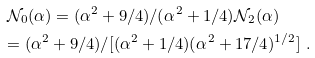<formula> <loc_0><loc_0><loc_500><loc_500>\mathcal { N } _ { 0 } ( \alpha ) = ( \alpha ^ { 2 } + 9 / 4 ) / ( \alpha ^ { 2 } + 1 / 4 ) \mathcal { N } _ { 2 } ( \alpha ) \quad \\ = ( \alpha ^ { 2 } + 9 / 4 ) / [ ( \alpha ^ { 2 } + 1 / 4 ) ( \alpha ^ { 2 } + 1 7 / 4 ) ^ { 1 / 2 } ] \ .</formula> 